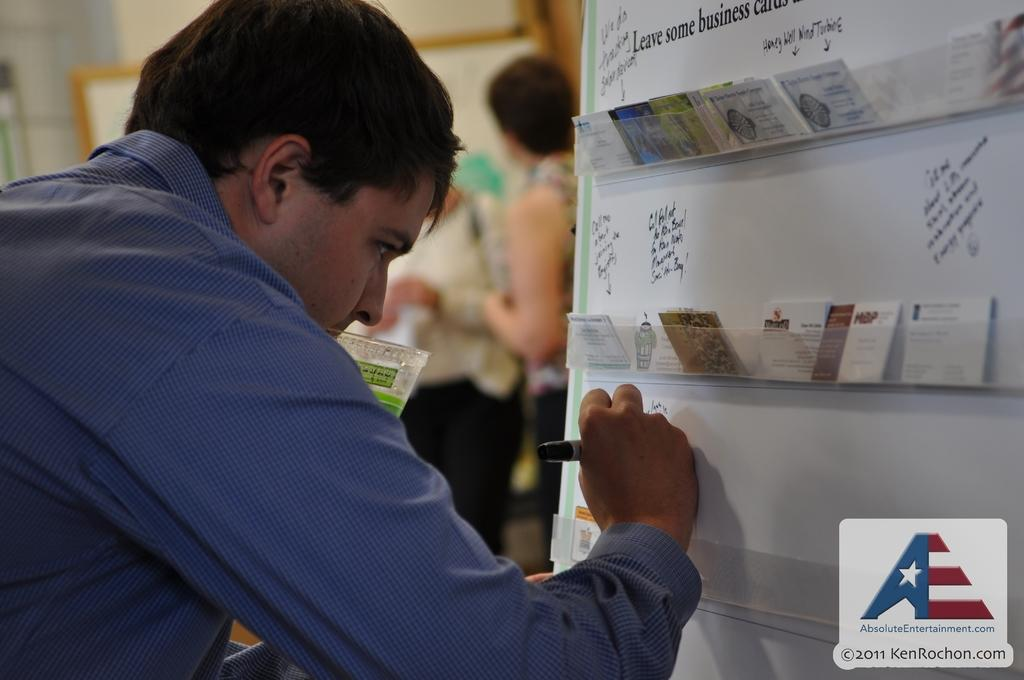<image>
Create a compact narrative representing the image presented. A man writing on a wall with the picture coming from Absoluteentertainment.com 